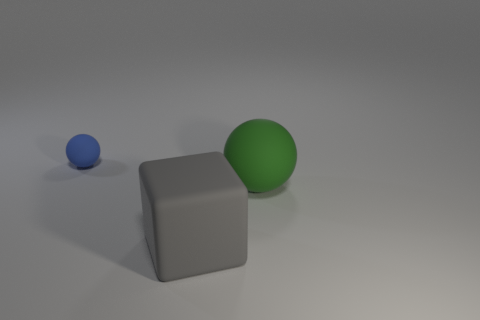Subtract all cubes. How many objects are left? 2 Add 2 red spheres. How many objects exist? 5 Subtract all green spheres. How many spheres are left? 1 Subtract 1 blocks. How many blocks are left? 0 Subtract all big rubber cubes. Subtract all spheres. How many objects are left? 0 Add 3 tiny matte objects. How many tiny matte objects are left? 4 Add 2 yellow balls. How many yellow balls exist? 2 Subtract 0 blue cubes. How many objects are left? 3 Subtract all green balls. Subtract all yellow blocks. How many balls are left? 1 Subtract all yellow cubes. How many gray balls are left? 0 